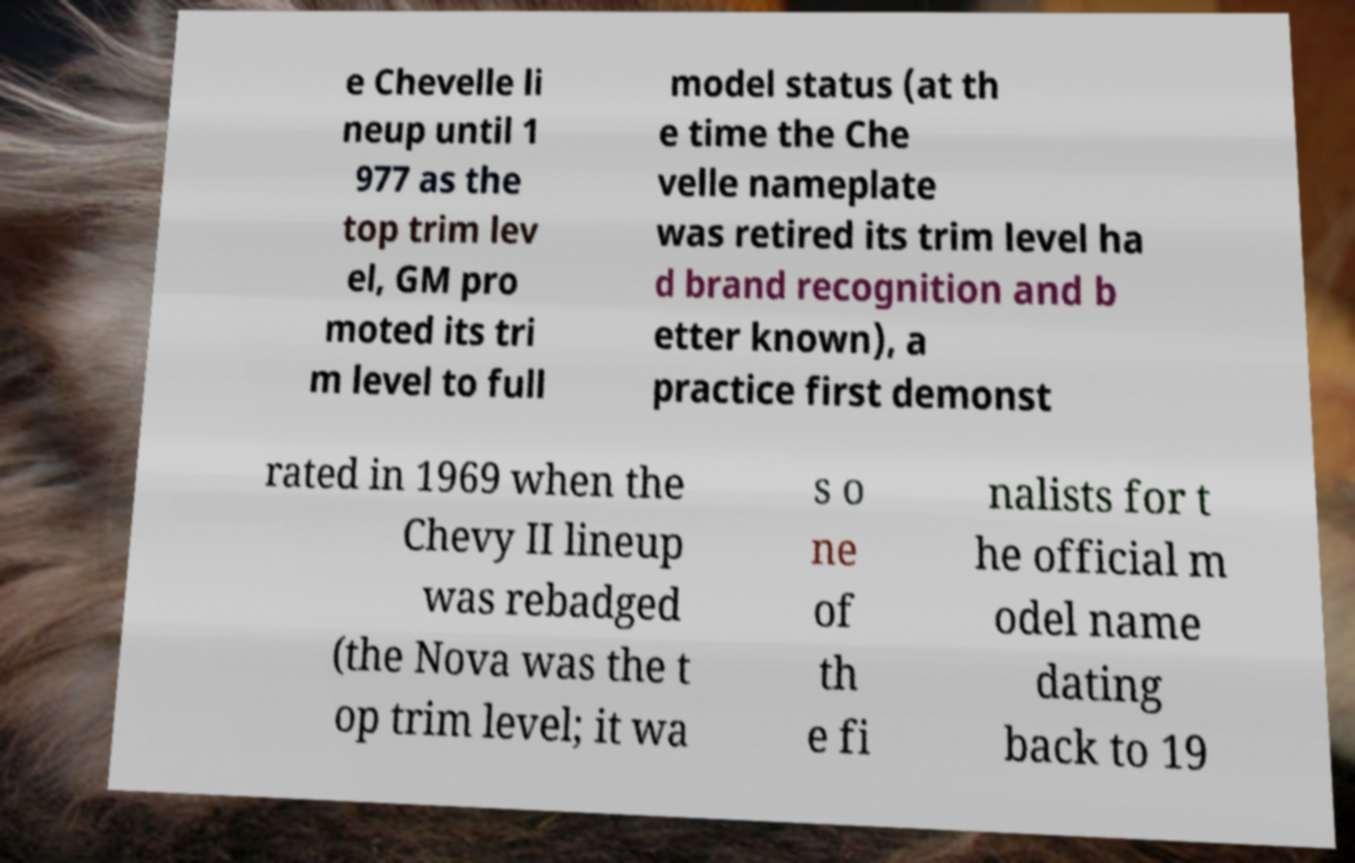Please identify and transcribe the text found in this image. e Chevelle li neup until 1 977 as the top trim lev el, GM pro moted its tri m level to full model status (at th e time the Che velle nameplate was retired its trim level ha d brand recognition and b etter known), a practice first demonst rated in 1969 when the Chevy II lineup was rebadged (the Nova was the t op trim level; it wa s o ne of th e fi nalists for t he official m odel name dating back to 19 